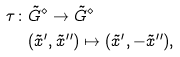<formula> <loc_0><loc_0><loc_500><loc_500>\tau \colon & \tilde { G } ^ { \diamond } \to \tilde { G } ^ { \diamond } \\ & ( \tilde { x } ^ { \prime } , \tilde { x } ^ { \prime \prime } ) \mapsto ( \tilde { x } ^ { \prime } , - \tilde { x } ^ { \prime \prime } ) ,</formula> 